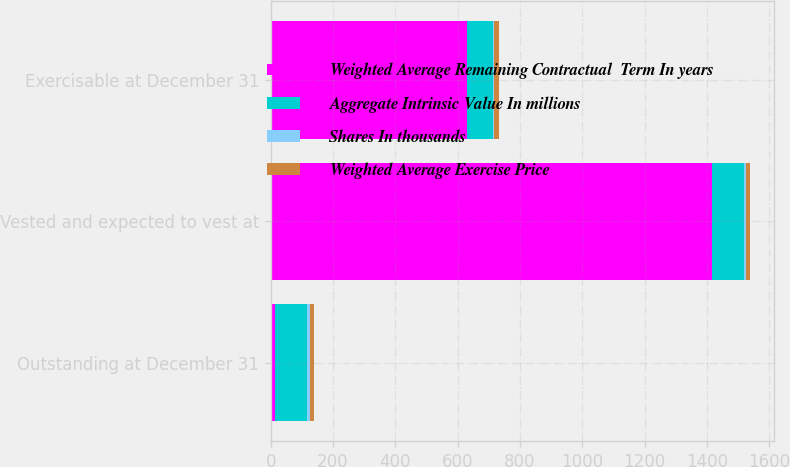<chart> <loc_0><loc_0><loc_500><loc_500><stacked_bar_chart><ecel><fcel>Outstanding at December 31<fcel>Vested and expected to vest at<fcel>Exercisable at December 31<nl><fcel>Weighted Average Remaining Contractual  Term In years<fcel>14<fcel>1415<fcel>631<nl><fcel>Aggregate Intrinsic Value In millions<fcel>103.5<fcel>103.01<fcel>80.81<nl><fcel>Shares In thousands<fcel>7.3<fcel>7.2<fcel>5.2<nl><fcel>Weighted Average Exercise Price<fcel>14<fcel>13.9<fcel>14<nl></chart> 